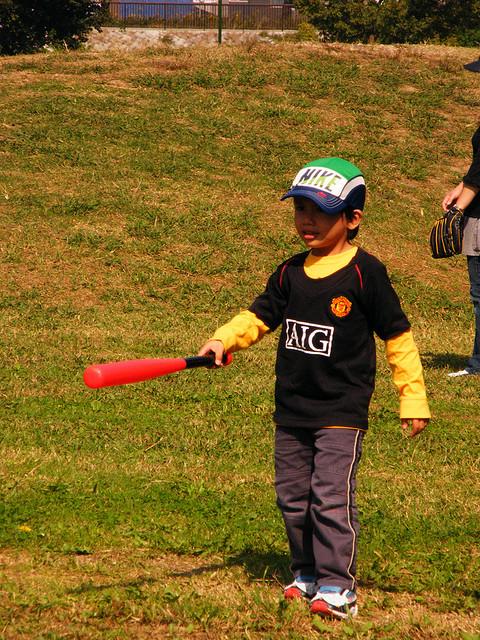Does the color of the bat match the boys uniform?
Answer briefly. No. How old is this boy?
Short answer required. 6. Is the kid posing for a picture?
Concise answer only. No. What is the primary color of the bat?
Keep it brief. Red. Where is the Nike hat?
Short answer required. On boy's head. 